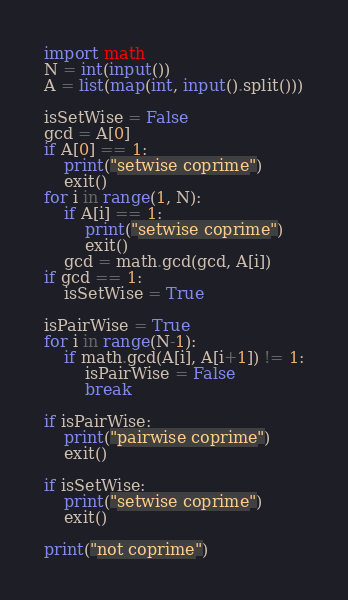<code> <loc_0><loc_0><loc_500><loc_500><_Python_>import math
N = int(input())
A = list(map(int, input().split()))

isSetWise = False
gcd = A[0]
if A[0] == 1:
    print("setwise coprime")
    exit()
for i in range(1, N):
    if A[i] == 1:
        print("setwise coprime")
        exit()
    gcd = math.gcd(gcd, A[i])
if gcd == 1:
    isSetWise = True

isPairWise = True
for i in range(N-1):
    if math.gcd(A[i], A[i+1]) != 1:
        isPairWise = False
        break

if isPairWise:
    print("pairwise coprime")
    exit()

if isSetWise:
    print("setwise coprime")
    exit()

print("not coprime")
</code> 